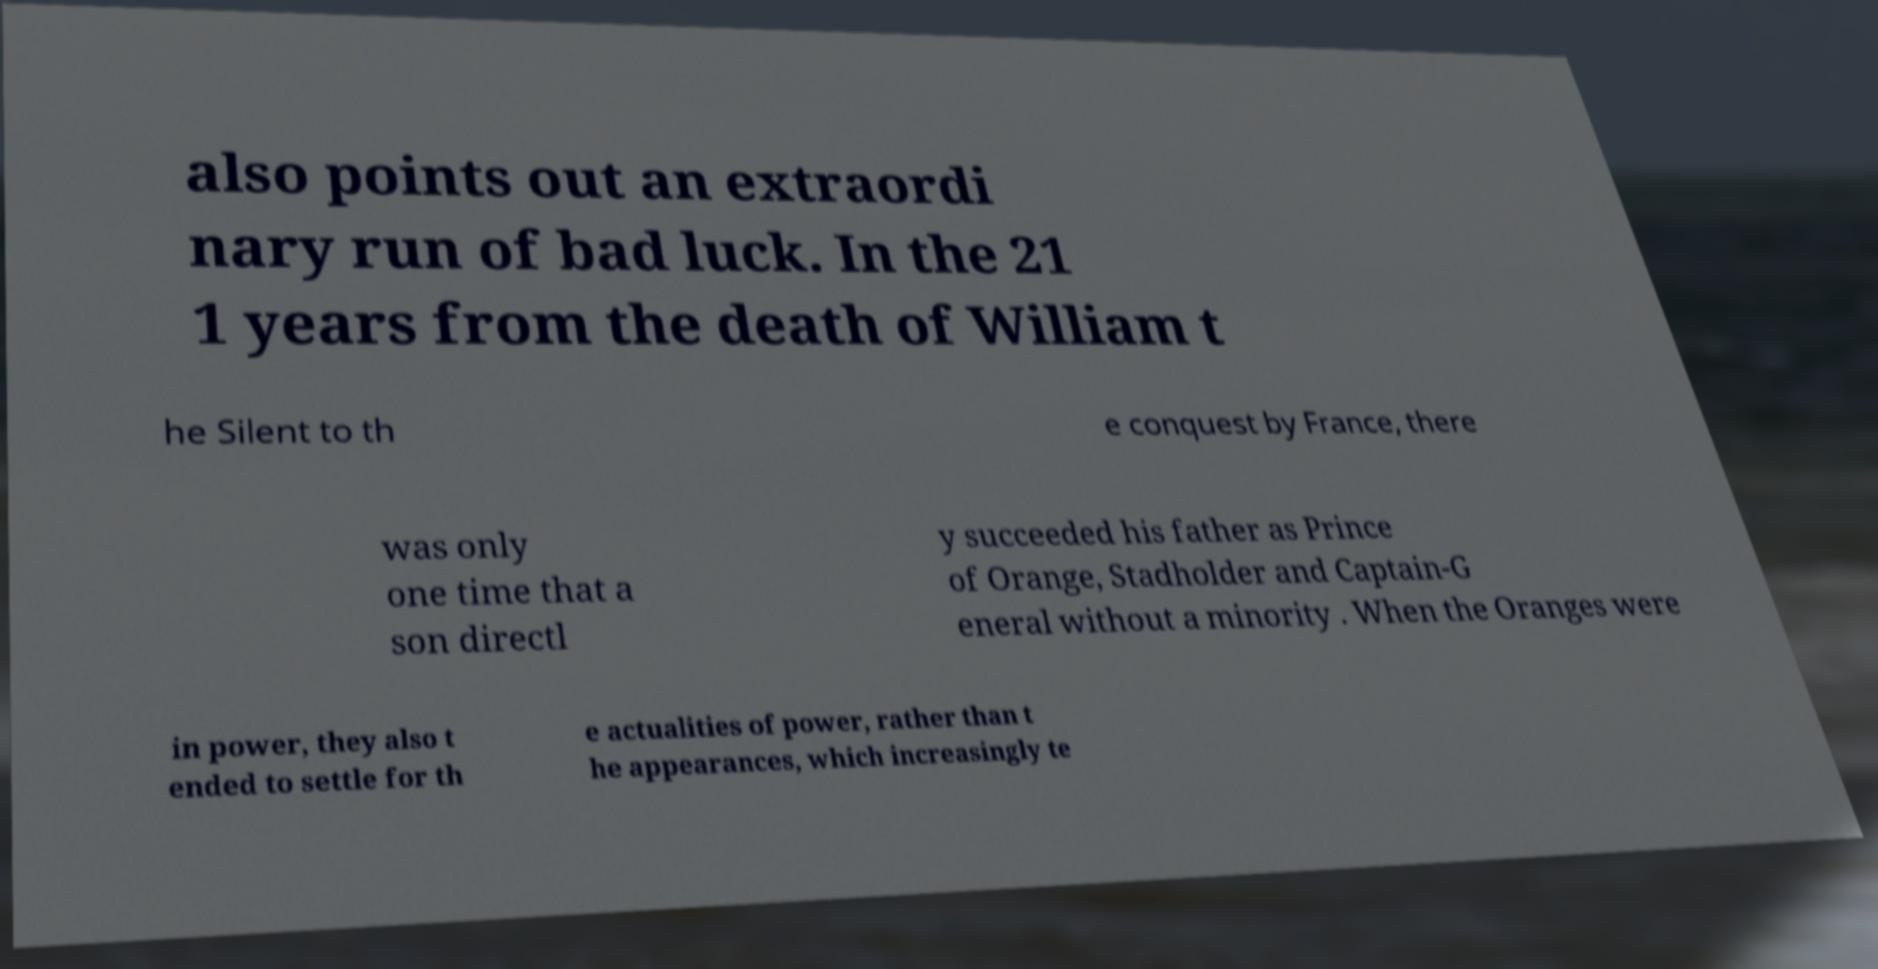Please read and relay the text visible in this image. What does it say? also points out an extraordi nary run of bad luck. In the 21 1 years from the death of William t he Silent to th e conquest by France, there was only one time that a son directl y succeeded his father as Prince of Orange, Stadholder and Captain-G eneral without a minority . When the Oranges were in power, they also t ended to settle for th e actualities of power, rather than t he appearances, which increasingly te 